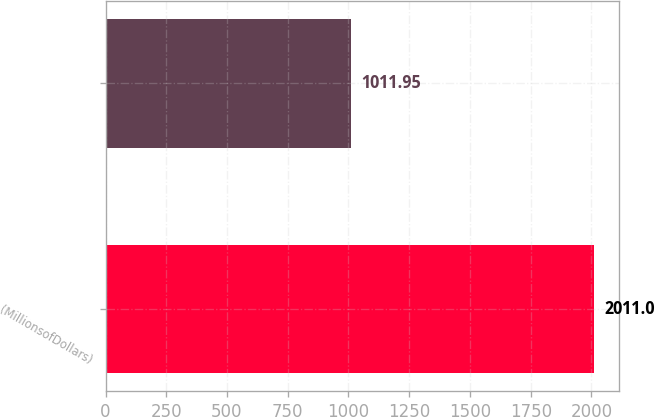Convert chart. <chart><loc_0><loc_0><loc_500><loc_500><bar_chart><fcel>(MillionsofDollars)<fcel>Unnamed: 1<nl><fcel>2011<fcel>1011.95<nl></chart> 